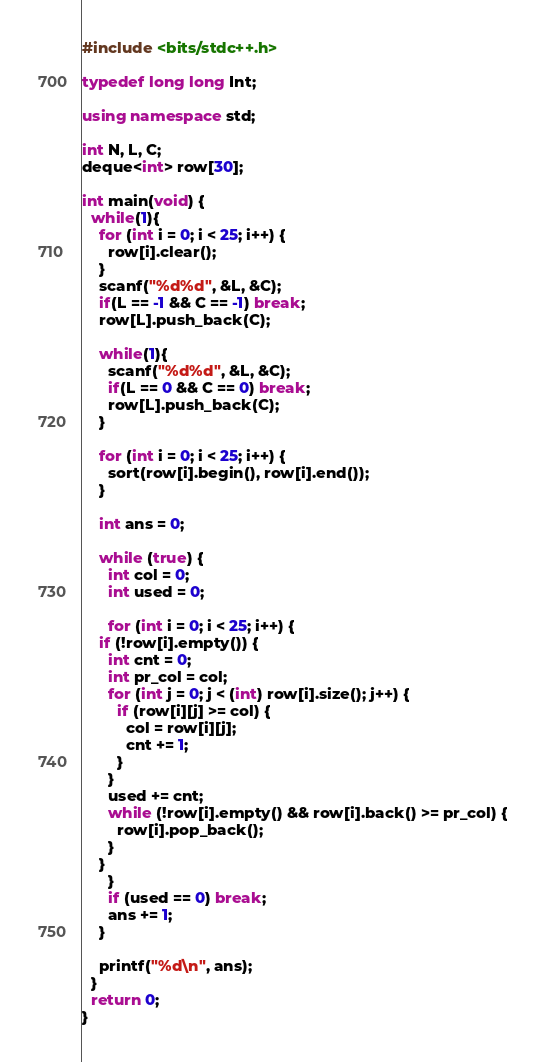<code> <loc_0><loc_0><loc_500><loc_500><_C++_>#include <bits/stdc++.h>

typedef long long Int;

using namespace std;

int N, L, C;
deque<int> row[30];

int main(void) {
  while(1){
    for (int i = 0; i < 25; i++) {
      row[i].clear();
    }
    scanf("%d%d", &L, &C);
    if(L == -1 && C == -1) break;
    row[L].push_back(C);
      
    while(1){
      scanf("%d%d", &L, &C);
      if(L == 0 && C == 0) break;
      row[L].push_back(C);
    }

    for (int i = 0; i < 25; i++) {
      sort(row[i].begin(), row[i].end());
    }
    
    int ans = 0;

    while (true) {
      int col = 0;
      int used = 0;

      for (int i = 0; i < 25; i++) {
	if (!row[i].empty()) {
	  int cnt = 0;
	  int pr_col = col;
	  for (int j = 0; j < (int) row[i].size(); j++) {
	    if (row[i][j] >= col) {
	      col = row[i][j];
	      cnt += 1;
	    }
	  }
	  used += cnt;
	  while (!row[i].empty() && row[i].back() >= pr_col) {
	    row[i].pop_back();
	  }
	}
      }
      if (used == 0) break;
      ans += 1;
    }

    printf("%d\n", ans);
  }
  return 0;
}
</code> 